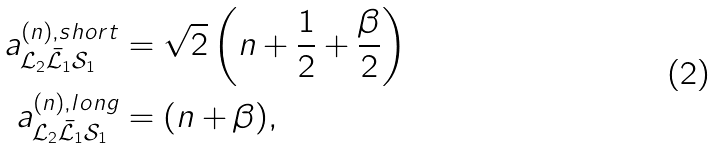Convert formula to latex. <formula><loc_0><loc_0><loc_500><loc_500>a ^ { ( n ) , s h o r t } _ { \mathcal { L } _ { 2 } \bar { \mathcal { L } } _ { 1 } \mathcal { S } _ { 1 } } & = \sqrt { 2 } \left ( n + \frac { 1 } { 2 } + \frac { \beta } { 2 } \right ) \\ a ^ { ( n ) , l o n g } _ { \mathcal { L } _ { 2 } \bar { \mathcal { L } } _ { 1 } \mathcal { S } _ { 1 } } & = ( n + \beta ) ,</formula> 